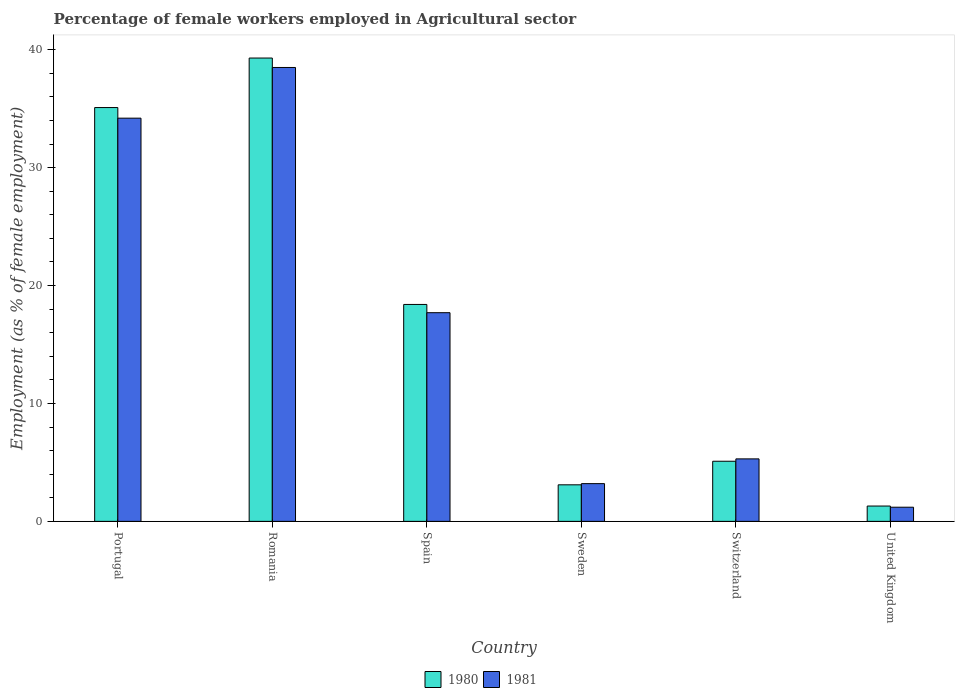How many different coloured bars are there?
Ensure brevity in your answer.  2. How many groups of bars are there?
Your response must be concise. 6. Are the number of bars per tick equal to the number of legend labels?
Make the answer very short. Yes. How many bars are there on the 6th tick from the right?
Offer a terse response. 2. In how many cases, is the number of bars for a given country not equal to the number of legend labels?
Provide a succinct answer. 0. What is the percentage of females employed in Agricultural sector in 1980 in United Kingdom?
Make the answer very short. 1.3. Across all countries, what is the maximum percentage of females employed in Agricultural sector in 1980?
Make the answer very short. 39.3. Across all countries, what is the minimum percentage of females employed in Agricultural sector in 1980?
Ensure brevity in your answer.  1.3. In which country was the percentage of females employed in Agricultural sector in 1980 maximum?
Provide a short and direct response. Romania. In which country was the percentage of females employed in Agricultural sector in 1980 minimum?
Provide a succinct answer. United Kingdom. What is the total percentage of females employed in Agricultural sector in 1980 in the graph?
Provide a short and direct response. 102.3. What is the difference between the percentage of females employed in Agricultural sector in 1981 in Spain and that in Sweden?
Provide a succinct answer. 14.5. What is the difference between the percentage of females employed in Agricultural sector in 1981 in Sweden and the percentage of females employed in Agricultural sector in 1980 in Spain?
Ensure brevity in your answer.  -15.2. What is the average percentage of females employed in Agricultural sector in 1980 per country?
Ensure brevity in your answer.  17.05. What is the difference between the percentage of females employed in Agricultural sector of/in 1980 and percentage of females employed in Agricultural sector of/in 1981 in Sweden?
Your answer should be compact. -0.1. In how many countries, is the percentage of females employed in Agricultural sector in 1981 greater than 20 %?
Give a very brief answer. 2. What is the ratio of the percentage of females employed in Agricultural sector in 1980 in Romania to that in Switzerland?
Make the answer very short. 7.71. What is the difference between the highest and the second highest percentage of females employed in Agricultural sector in 1980?
Make the answer very short. -16.7. What is the difference between the highest and the lowest percentage of females employed in Agricultural sector in 1981?
Ensure brevity in your answer.  37.3. In how many countries, is the percentage of females employed in Agricultural sector in 1981 greater than the average percentage of females employed in Agricultural sector in 1981 taken over all countries?
Your response must be concise. 3. What does the 1st bar from the left in Portugal represents?
Your answer should be very brief. 1980. What does the 2nd bar from the right in Switzerland represents?
Your answer should be very brief. 1980. Are all the bars in the graph horizontal?
Make the answer very short. No. How many countries are there in the graph?
Make the answer very short. 6. How many legend labels are there?
Provide a succinct answer. 2. How are the legend labels stacked?
Ensure brevity in your answer.  Horizontal. What is the title of the graph?
Your answer should be compact. Percentage of female workers employed in Agricultural sector. Does "1970" appear as one of the legend labels in the graph?
Provide a short and direct response. No. What is the label or title of the Y-axis?
Provide a short and direct response. Employment (as % of female employment). What is the Employment (as % of female employment) in 1980 in Portugal?
Make the answer very short. 35.1. What is the Employment (as % of female employment) of 1981 in Portugal?
Provide a succinct answer. 34.2. What is the Employment (as % of female employment) in 1980 in Romania?
Your answer should be compact. 39.3. What is the Employment (as % of female employment) in 1981 in Romania?
Your answer should be very brief. 38.5. What is the Employment (as % of female employment) of 1980 in Spain?
Offer a terse response. 18.4. What is the Employment (as % of female employment) of 1981 in Spain?
Your response must be concise. 17.7. What is the Employment (as % of female employment) of 1980 in Sweden?
Provide a short and direct response. 3.1. What is the Employment (as % of female employment) of 1981 in Sweden?
Your response must be concise. 3.2. What is the Employment (as % of female employment) in 1980 in Switzerland?
Offer a very short reply. 5.1. What is the Employment (as % of female employment) of 1981 in Switzerland?
Ensure brevity in your answer.  5.3. What is the Employment (as % of female employment) of 1980 in United Kingdom?
Give a very brief answer. 1.3. What is the Employment (as % of female employment) in 1981 in United Kingdom?
Your answer should be compact. 1.2. Across all countries, what is the maximum Employment (as % of female employment) of 1980?
Provide a short and direct response. 39.3. Across all countries, what is the maximum Employment (as % of female employment) of 1981?
Provide a succinct answer. 38.5. Across all countries, what is the minimum Employment (as % of female employment) in 1980?
Ensure brevity in your answer.  1.3. Across all countries, what is the minimum Employment (as % of female employment) in 1981?
Ensure brevity in your answer.  1.2. What is the total Employment (as % of female employment) of 1980 in the graph?
Your response must be concise. 102.3. What is the total Employment (as % of female employment) in 1981 in the graph?
Make the answer very short. 100.1. What is the difference between the Employment (as % of female employment) in 1981 in Portugal and that in Romania?
Offer a very short reply. -4.3. What is the difference between the Employment (as % of female employment) in 1980 in Portugal and that in Spain?
Provide a succinct answer. 16.7. What is the difference between the Employment (as % of female employment) of 1981 in Portugal and that in Spain?
Your answer should be compact. 16.5. What is the difference between the Employment (as % of female employment) in 1980 in Portugal and that in Sweden?
Your answer should be very brief. 32. What is the difference between the Employment (as % of female employment) of 1981 in Portugal and that in Switzerland?
Your response must be concise. 28.9. What is the difference between the Employment (as % of female employment) in 1980 in Portugal and that in United Kingdom?
Offer a very short reply. 33.8. What is the difference between the Employment (as % of female employment) in 1981 in Portugal and that in United Kingdom?
Give a very brief answer. 33. What is the difference between the Employment (as % of female employment) in 1980 in Romania and that in Spain?
Your answer should be very brief. 20.9. What is the difference between the Employment (as % of female employment) in 1981 in Romania and that in Spain?
Your answer should be very brief. 20.8. What is the difference between the Employment (as % of female employment) of 1980 in Romania and that in Sweden?
Ensure brevity in your answer.  36.2. What is the difference between the Employment (as % of female employment) of 1981 in Romania and that in Sweden?
Your answer should be compact. 35.3. What is the difference between the Employment (as % of female employment) in 1980 in Romania and that in Switzerland?
Your answer should be very brief. 34.2. What is the difference between the Employment (as % of female employment) in 1981 in Romania and that in Switzerland?
Your response must be concise. 33.2. What is the difference between the Employment (as % of female employment) in 1981 in Romania and that in United Kingdom?
Offer a very short reply. 37.3. What is the difference between the Employment (as % of female employment) in 1980 in Spain and that in Switzerland?
Offer a very short reply. 13.3. What is the difference between the Employment (as % of female employment) in 1981 in Spain and that in Switzerland?
Your response must be concise. 12.4. What is the difference between the Employment (as % of female employment) of 1980 in Spain and that in United Kingdom?
Offer a very short reply. 17.1. What is the difference between the Employment (as % of female employment) in 1981 in Spain and that in United Kingdom?
Offer a terse response. 16.5. What is the difference between the Employment (as % of female employment) in 1980 in Sweden and that in Switzerland?
Your answer should be very brief. -2. What is the difference between the Employment (as % of female employment) in 1980 in Sweden and that in United Kingdom?
Provide a succinct answer. 1.8. What is the difference between the Employment (as % of female employment) in 1981 in Sweden and that in United Kingdom?
Your answer should be compact. 2. What is the difference between the Employment (as % of female employment) in 1980 in Portugal and the Employment (as % of female employment) in 1981 in Spain?
Make the answer very short. 17.4. What is the difference between the Employment (as % of female employment) in 1980 in Portugal and the Employment (as % of female employment) in 1981 in Sweden?
Your answer should be very brief. 31.9. What is the difference between the Employment (as % of female employment) in 1980 in Portugal and the Employment (as % of female employment) in 1981 in Switzerland?
Make the answer very short. 29.8. What is the difference between the Employment (as % of female employment) of 1980 in Portugal and the Employment (as % of female employment) of 1981 in United Kingdom?
Provide a succinct answer. 33.9. What is the difference between the Employment (as % of female employment) of 1980 in Romania and the Employment (as % of female employment) of 1981 in Spain?
Your answer should be very brief. 21.6. What is the difference between the Employment (as % of female employment) in 1980 in Romania and the Employment (as % of female employment) in 1981 in Sweden?
Ensure brevity in your answer.  36.1. What is the difference between the Employment (as % of female employment) of 1980 in Romania and the Employment (as % of female employment) of 1981 in United Kingdom?
Provide a succinct answer. 38.1. What is the difference between the Employment (as % of female employment) of 1980 in Spain and the Employment (as % of female employment) of 1981 in Switzerland?
Make the answer very short. 13.1. What is the difference between the Employment (as % of female employment) of 1980 in Sweden and the Employment (as % of female employment) of 1981 in Switzerland?
Give a very brief answer. -2.2. What is the difference between the Employment (as % of female employment) of 1980 in Sweden and the Employment (as % of female employment) of 1981 in United Kingdom?
Offer a very short reply. 1.9. What is the difference between the Employment (as % of female employment) of 1980 in Switzerland and the Employment (as % of female employment) of 1981 in United Kingdom?
Give a very brief answer. 3.9. What is the average Employment (as % of female employment) in 1980 per country?
Your response must be concise. 17.05. What is the average Employment (as % of female employment) in 1981 per country?
Give a very brief answer. 16.68. What is the difference between the Employment (as % of female employment) in 1980 and Employment (as % of female employment) in 1981 in Portugal?
Your answer should be compact. 0.9. What is the difference between the Employment (as % of female employment) in 1980 and Employment (as % of female employment) in 1981 in Switzerland?
Provide a succinct answer. -0.2. What is the difference between the Employment (as % of female employment) of 1980 and Employment (as % of female employment) of 1981 in United Kingdom?
Keep it short and to the point. 0.1. What is the ratio of the Employment (as % of female employment) in 1980 in Portugal to that in Romania?
Give a very brief answer. 0.89. What is the ratio of the Employment (as % of female employment) of 1981 in Portugal to that in Romania?
Your answer should be compact. 0.89. What is the ratio of the Employment (as % of female employment) in 1980 in Portugal to that in Spain?
Your response must be concise. 1.91. What is the ratio of the Employment (as % of female employment) of 1981 in Portugal to that in Spain?
Provide a succinct answer. 1.93. What is the ratio of the Employment (as % of female employment) in 1980 in Portugal to that in Sweden?
Make the answer very short. 11.32. What is the ratio of the Employment (as % of female employment) of 1981 in Portugal to that in Sweden?
Provide a succinct answer. 10.69. What is the ratio of the Employment (as % of female employment) of 1980 in Portugal to that in Switzerland?
Your answer should be very brief. 6.88. What is the ratio of the Employment (as % of female employment) of 1981 in Portugal to that in Switzerland?
Offer a terse response. 6.45. What is the ratio of the Employment (as % of female employment) of 1980 in Romania to that in Spain?
Your response must be concise. 2.14. What is the ratio of the Employment (as % of female employment) in 1981 in Romania to that in Spain?
Make the answer very short. 2.18. What is the ratio of the Employment (as % of female employment) in 1980 in Romania to that in Sweden?
Provide a short and direct response. 12.68. What is the ratio of the Employment (as % of female employment) in 1981 in Romania to that in Sweden?
Provide a short and direct response. 12.03. What is the ratio of the Employment (as % of female employment) of 1980 in Romania to that in Switzerland?
Give a very brief answer. 7.71. What is the ratio of the Employment (as % of female employment) in 1981 in Romania to that in Switzerland?
Ensure brevity in your answer.  7.26. What is the ratio of the Employment (as % of female employment) in 1980 in Romania to that in United Kingdom?
Provide a succinct answer. 30.23. What is the ratio of the Employment (as % of female employment) in 1981 in Romania to that in United Kingdom?
Keep it short and to the point. 32.08. What is the ratio of the Employment (as % of female employment) of 1980 in Spain to that in Sweden?
Ensure brevity in your answer.  5.94. What is the ratio of the Employment (as % of female employment) in 1981 in Spain to that in Sweden?
Offer a very short reply. 5.53. What is the ratio of the Employment (as % of female employment) of 1980 in Spain to that in Switzerland?
Offer a terse response. 3.61. What is the ratio of the Employment (as % of female employment) of 1981 in Spain to that in Switzerland?
Keep it short and to the point. 3.34. What is the ratio of the Employment (as % of female employment) in 1980 in Spain to that in United Kingdom?
Your answer should be very brief. 14.15. What is the ratio of the Employment (as % of female employment) of 1981 in Spain to that in United Kingdom?
Keep it short and to the point. 14.75. What is the ratio of the Employment (as % of female employment) of 1980 in Sweden to that in Switzerland?
Keep it short and to the point. 0.61. What is the ratio of the Employment (as % of female employment) of 1981 in Sweden to that in Switzerland?
Your answer should be compact. 0.6. What is the ratio of the Employment (as % of female employment) in 1980 in Sweden to that in United Kingdom?
Ensure brevity in your answer.  2.38. What is the ratio of the Employment (as % of female employment) of 1981 in Sweden to that in United Kingdom?
Provide a succinct answer. 2.67. What is the ratio of the Employment (as % of female employment) in 1980 in Switzerland to that in United Kingdom?
Ensure brevity in your answer.  3.92. What is the ratio of the Employment (as % of female employment) of 1981 in Switzerland to that in United Kingdom?
Your answer should be very brief. 4.42. What is the difference between the highest and the second highest Employment (as % of female employment) in 1981?
Your response must be concise. 4.3. What is the difference between the highest and the lowest Employment (as % of female employment) in 1980?
Your answer should be compact. 38. What is the difference between the highest and the lowest Employment (as % of female employment) in 1981?
Keep it short and to the point. 37.3. 